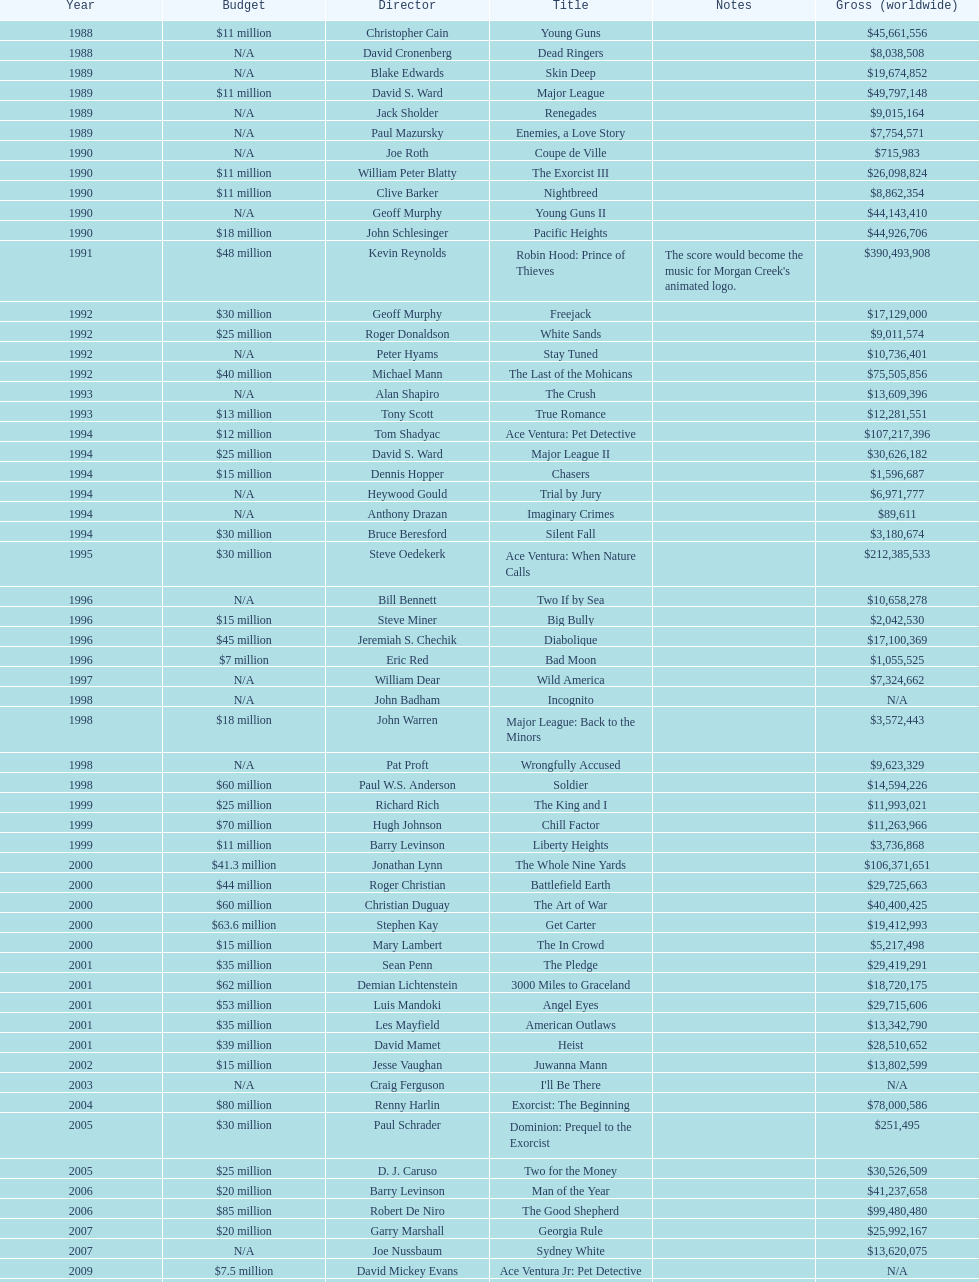How many films were there in 1990? 5. 